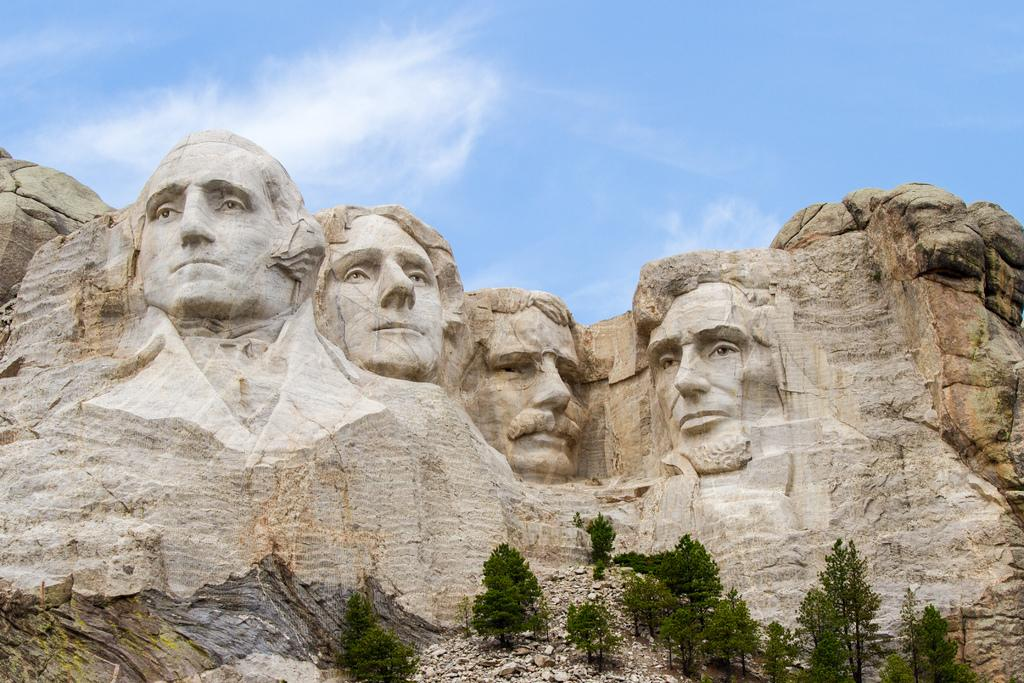What type of sculptures can be seen on the hills in the image? There are sculptures of men on the hills in the image. What other natural elements are present in the image? There are trees and rocks in the image. What is visible in the background of the image? The sky is visible in the image. What is the condition of the sky in the image? Clouds are present in the sky. What type of hospital can be seen in the image? There is no hospital present in the image; it features hills with sculptures of men, trees, rocks, and a sky with clouds. What emotion do the sculptures of men convey in the image? The sculptures of men are stationary objects and do not convey emotions like fear. 